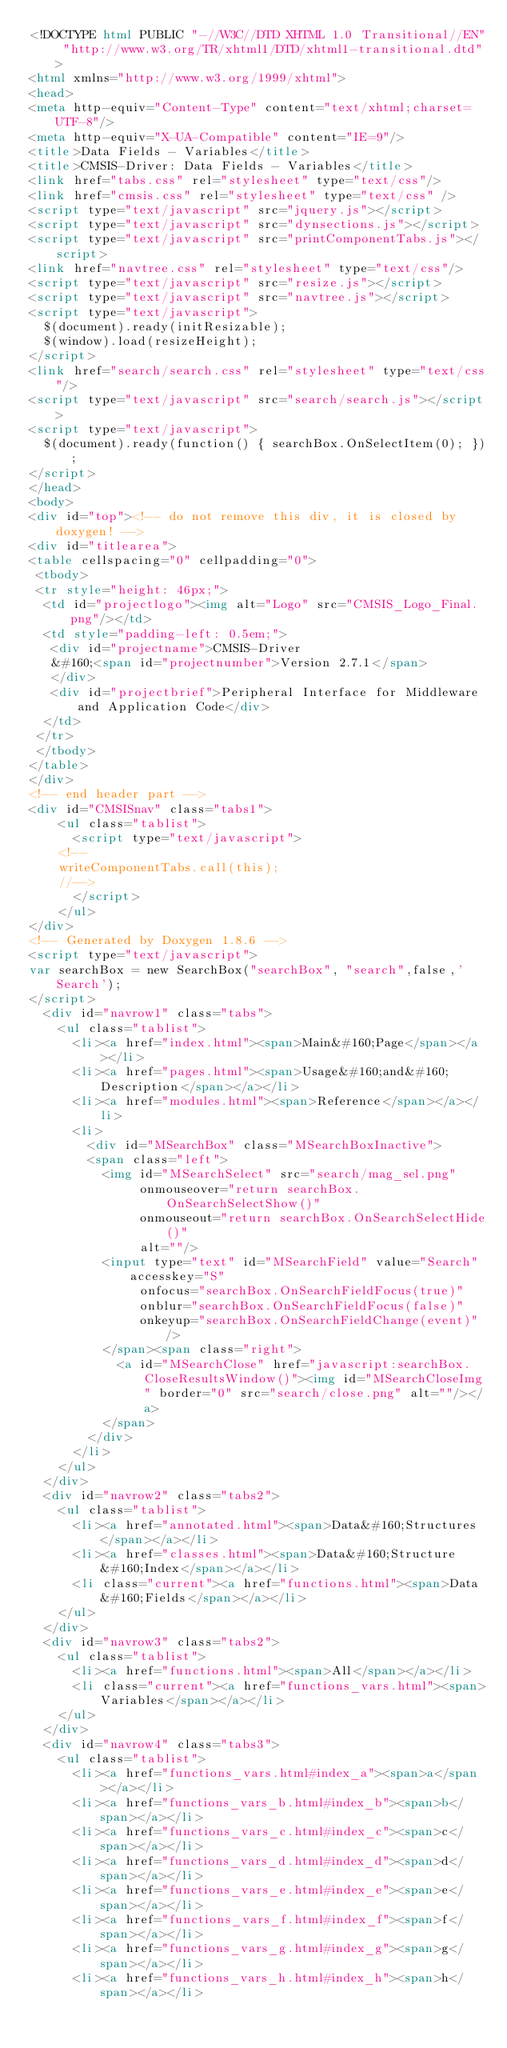<code> <loc_0><loc_0><loc_500><loc_500><_HTML_><!DOCTYPE html PUBLIC "-//W3C//DTD XHTML 1.0 Transitional//EN" "http://www.w3.org/TR/xhtml1/DTD/xhtml1-transitional.dtd">
<html xmlns="http://www.w3.org/1999/xhtml">
<head>
<meta http-equiv="Content-Type" content="text/xhtml;charset=UTF-8"/>
<meta http-equiv="X-UA-Compatible" content="IE=9"/>
<title>Data Fields - Variables</title>
<title>CMSIS-Driver: Data Fields - Variables</title>
<link href="tabs.css" rel="stylesheet" type="text/css"/>
<link href="cmsis.css" rel="stylesheet" type="text/css" />
<script type="text/javascript" src="jquery.js"></script>
<script type="text/javascript" src="dynsections.js"></script>
<script type="text/javascript" src="printComponentTabs.js"></script>
<link href="navtree.css" rel="stylesheet" type="text/css"/>
<script type="text/javascript" src="resize.js"></script>
<script type="text/javascript" src="navtree.js"></script>
<script type="text/javascript">
  $(document).ready(initResizable);
  $(window).load(resizeHeight);
</script>
<link href="search/search.css" rel="stylesheet" type="text/css"/>
<script type="text/javascript" src="search/search.js"></script>
<script type="text/javascript">
  $(document).ready(function() { searchBox.OnSelectItem(0); });
</script>
</head>
<body>
<div id="top"><!-- do not remove this div, it is closed by doxygen! -->
<div id="titlearea">
<table cellspacing="0" cellpadding="0">
 <tbody>
 <tr style="height: 46px;">
  <td id="projectlogo"><img alt="Logo" src="CMSIS_Logo_Final.png"/></td>
  <td style="padding-left: 0.5em;">
   <div id="projectname">CMSIS-Driver
   &#160;<span id="projectnumber">Version 2.7.1</span>
   </div>
   <div id="projectbrief">Peripheral Interface for Middleware and Application Code</div>
  </td>
 </tr>
 </tbody>
</table>
</div>
<!-- end header part -->
<div id="CMSISnav" class="tabs1">
    <ul class="tablist">
      <script type="text/javascript">
		<!--
		writeComponentTabs.call(this);
		//-->
      </script>
	  </ul>
</div>
<!-- Generated by Doxygen 1.8.6 -->
<script type="text/javascript">
var searchBox = new SearchBox("searchBox", "search",false,'Search');
</script>
  <div id="navrow1" class="tabs">
    <ul class="tablist">
      <li><a href="index.html"><span>Main&#160;Page</span></a></li>
      <li><a href="pages.html"><span>Usage&#160;and&#160;Description</span></a></li>
      <li><a href="modules.html"><span>Reference</span></a></li>
      <li>
        <div id="MSearchBox" class="MSearchBoxInactive">
        <span class="left">
          <img id="MSearchSelect" src="search/mag_sel.png"
               onmouseover="return searchBox.OnSearchSelectShow()"
               onmouseout="return searchBox.OnSearchSelectHide()"
               alt=""/>
          <input type="text" id="MSearchField" value="Search" accesskey="S"
               onfocus="searchBox.OnSearchFieldFocus(true)" 
               onblur="searchBox.OnSearchFieldFocus(false)" 
               onkeyup="searchBox.OnSearchFieldChange(event)"/>
          </span><span class="right">
            <a id="MSearchClose" href="javascript:searchBox.CloseResultsWindow()"><img id="MSearchCloseImg" border="0" src="search/close.png" alt=""/></a>
          </span>
        </div>
      </li>
    </ul>
  </div>
  <div id="navrow2" class="tabs2">
    <ul class="tablist">
      <li><a href="annotated.html"><span>Data&#160;Structures</span></a></li>
      <li><a href="classes.html"><span>Data&#160;Structure&#160;Index</span></a></li>
      <li class="current"><a href="functions.html"><span>Data&#160;Fields</span></a></li>
    </ul>
  </div>
  <div id="navrow3" class="tabs2">
    <ul class="tablist">
      <li><a href="functions.html"><span>All</span></a></li>
      <li class="current"><a href="functions_vars.html"><span>Variables</span></a></li>
    </ul>
  </div>
  <div id="navrow4" class="tabs3">
    <ul class="tablist">
      <li><a href="functions_vars.html#index_a"><span>a</span></a></li>
      <li><a href="functions_vars_b.html#index_b"><span>b</span></a></li>
      <li><a href="functions_vars_c.html#index_c"><span>c</span></a></li>
      <li><a href="functions_vars_d.html#index_d"><span>d</span></a></li>
      <li><a href="functions_vars_e.html#index_e"><span>e</span></a></li>
      <li><a href="functions_vars_f.html#index_f"><span>f</span></a></li>
      <li><a href="functions_vars_g.html#index_g"><span>g</span></a></li>
      <li><a href="functions_vars_h.html#index_h"><span>h</span></a></li></code> 